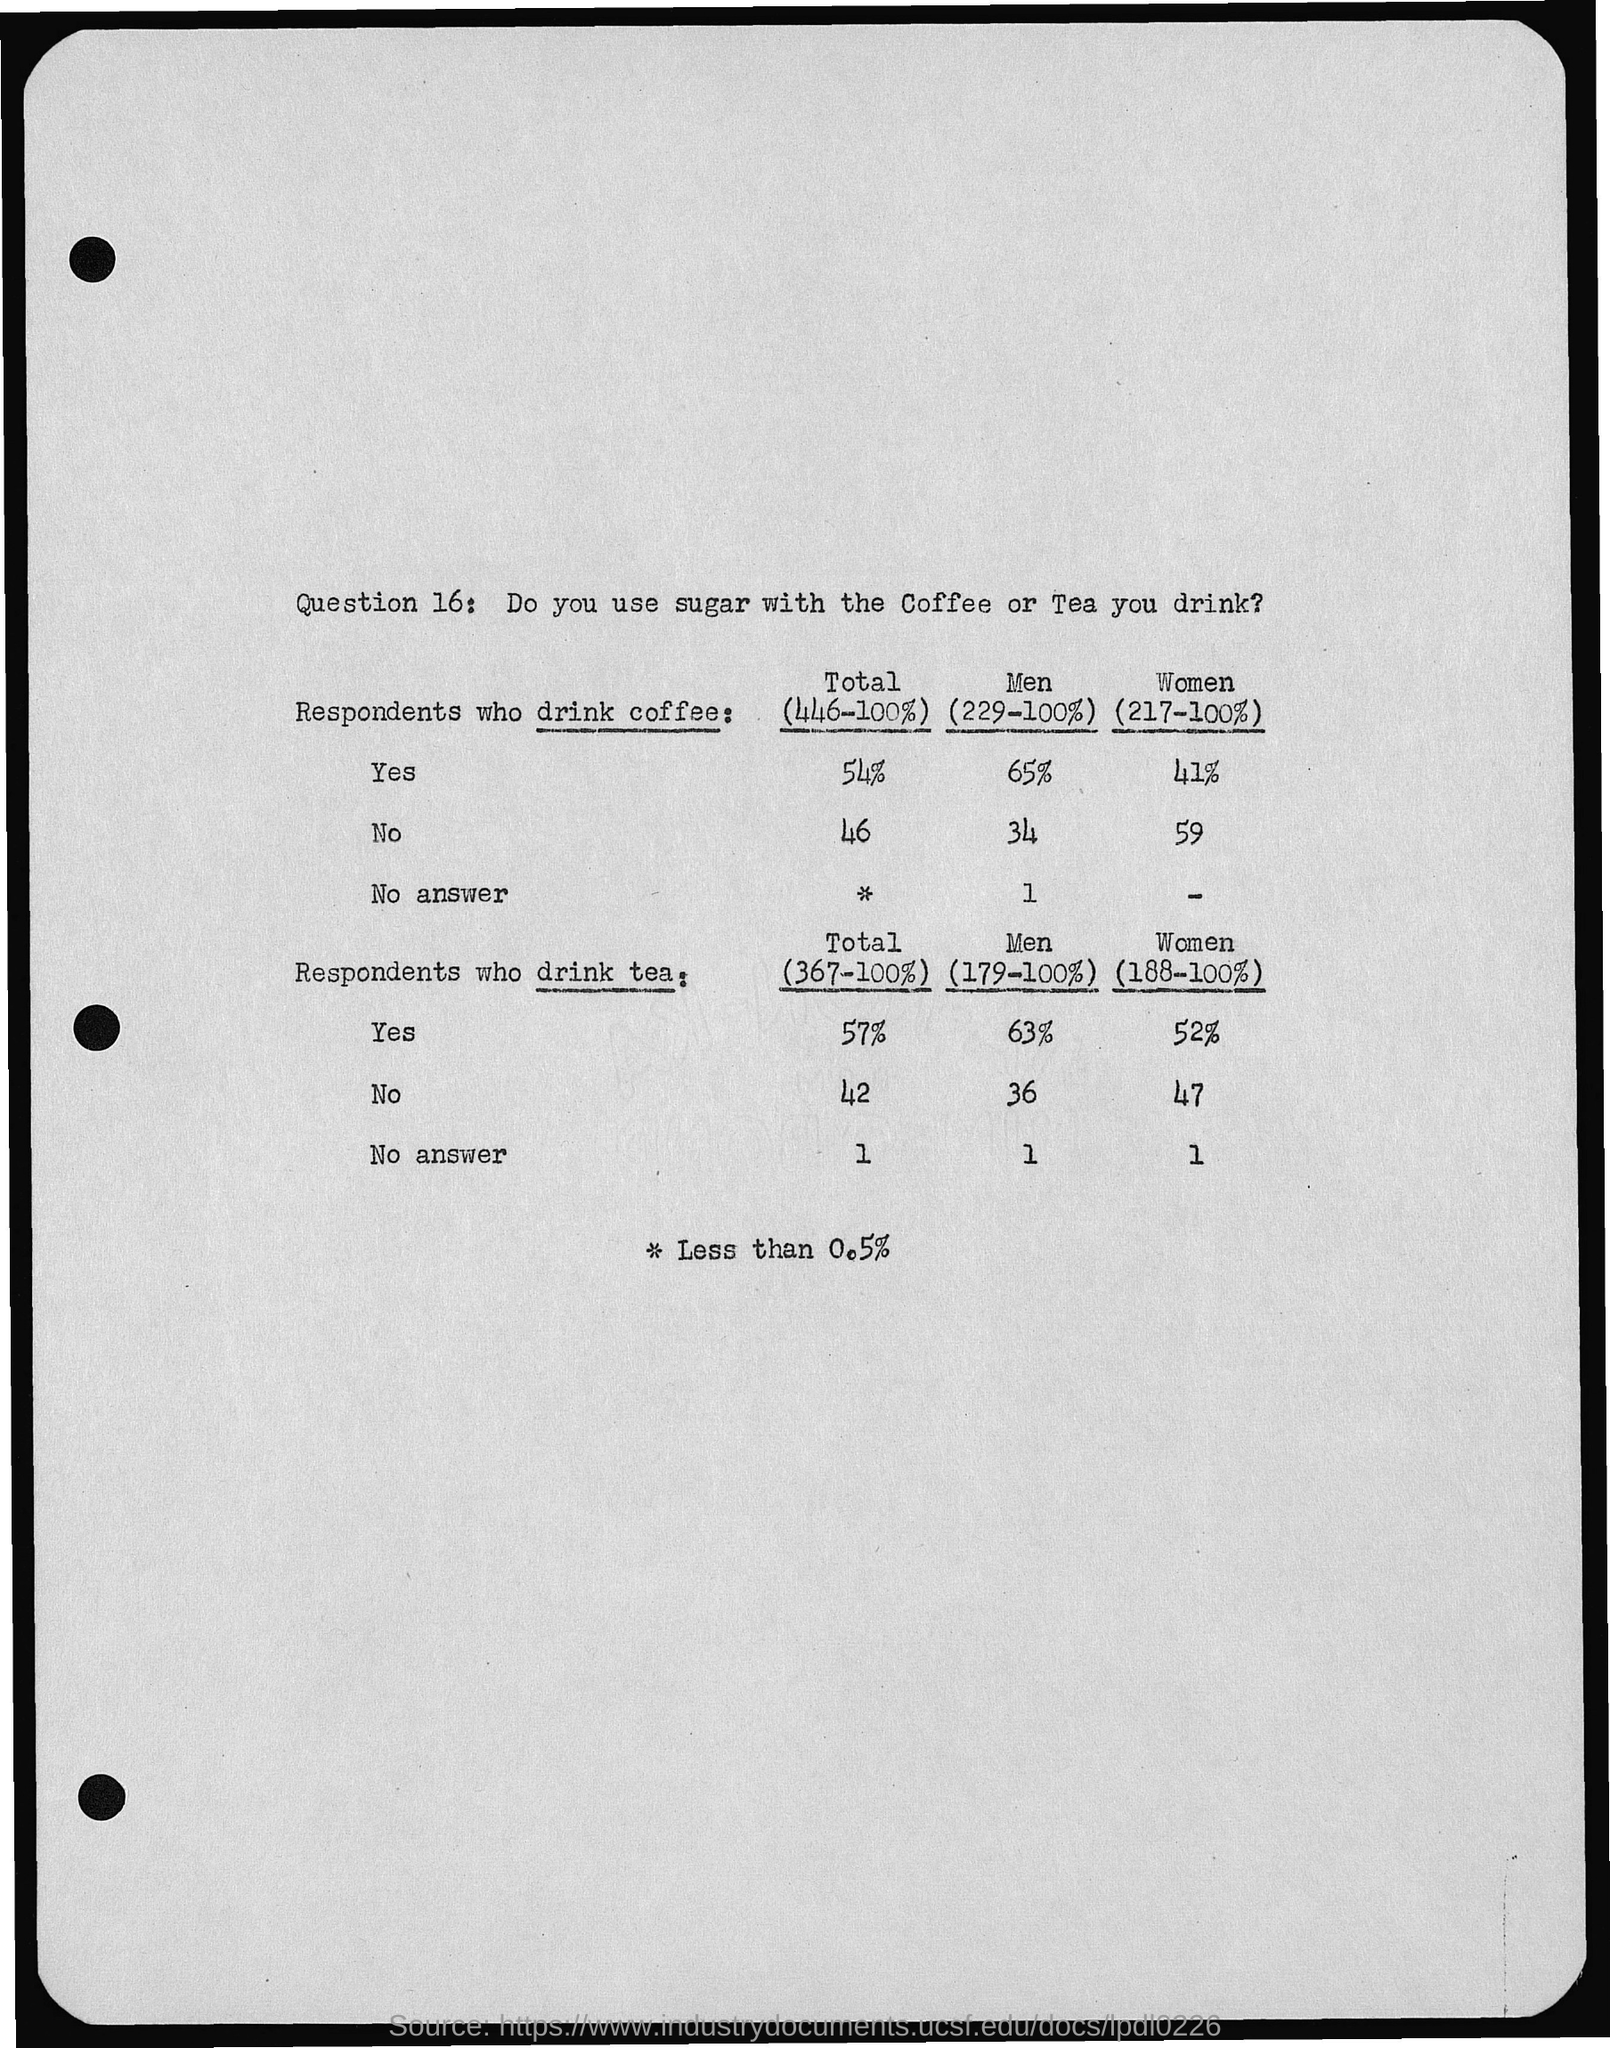Point out several critical features in this image. According to a recent study, 52% of women consume tea on a regular basis. It is estimated that approximately 34% of men do not consume coffee. The question of whether sugar is used with coffee or tea is Question 16. Do you consume sugar alongside your coffee or tea? According to a recent survey, 65% of men consume coffee on a regular basis. According to a survey, 41% of women consume coffee. 